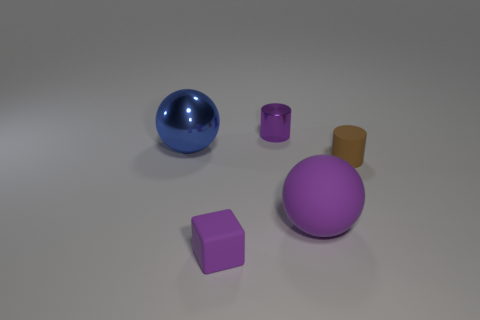Do the tiny metallic cylinder and the matte sphere have the same color?
Offer a terse response. Yes. How many purple things are both right of the purple block and in front of the tiny brown rubber cylinder?
Your answer should be compact. 1. The purple object that is the same size as the purple matte cube is what shape?
Your answer should be very brief. Cylinder. Are there any large things on the right side of the small purple object that is in front of the large thing on the right side of the metallic ball?
Make the answer very short. Yes. Does the big metal thing have the same color as the big object that is in front of the big blue ball?
Provide a succinct answer. No. What number of tiny metal objects are the same color as the tiny matte block?
Offer a very short reply. 1. What size is the purple thing that is in front of the big thing that is to the right of the purple metal thing?
Your answer should be compact. Small. How many things are either things that are to the right of the tiny metal thing or purple metal cylinders?
Your answer should be compact. 3. Is there another brown cylinder of the same size as the rubber cylinder?
Your answer should be very brief. No. Are there any spheres left of the big object that is on the left side of the rubber cube?
Make the answer very short. No. 